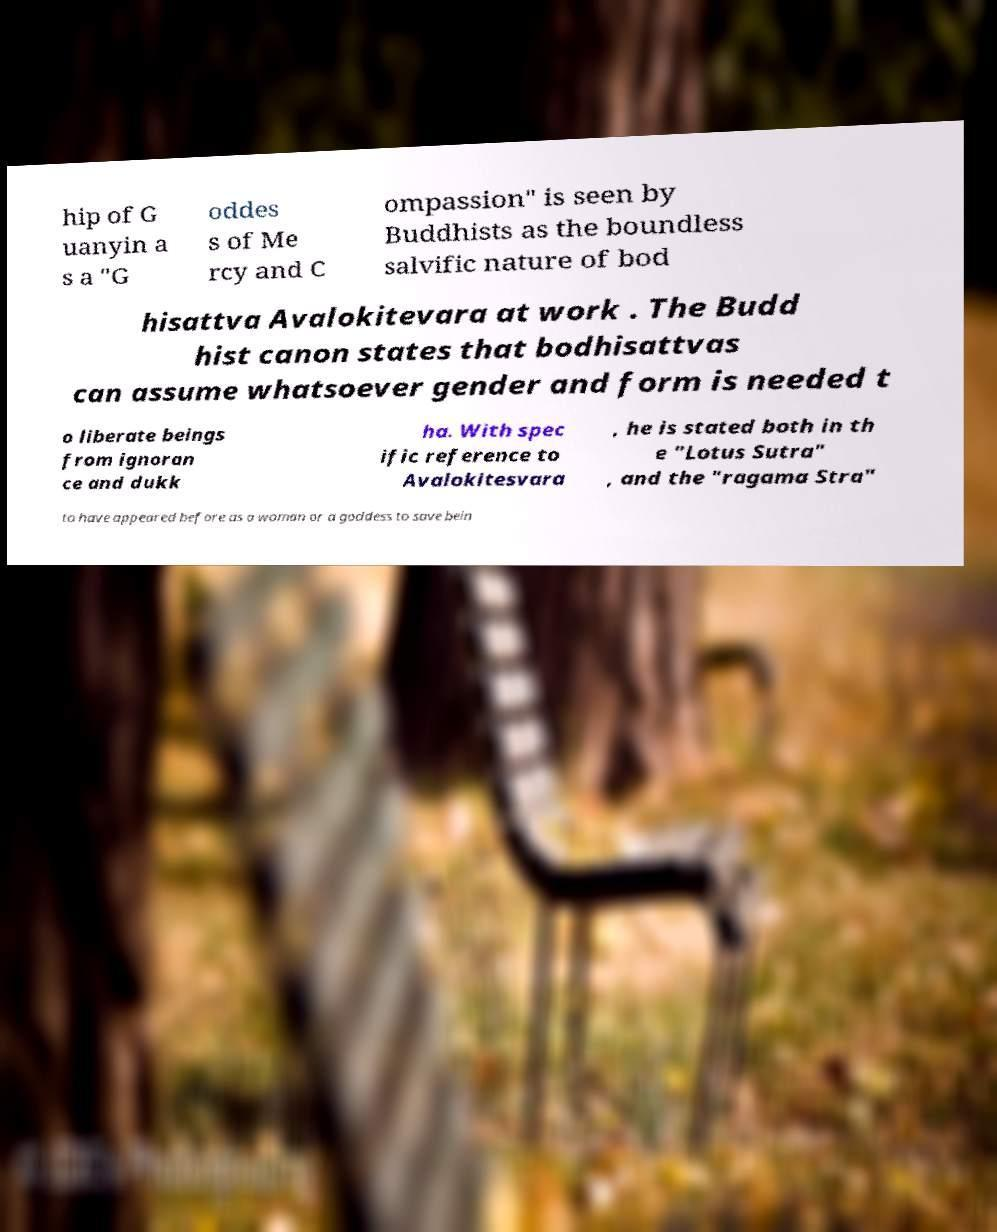Can you accurately transcribe the text from the provided image for me? hip of G uanyin a s a "G oddes s of Me rcy and C ompassion" is seen by Buddhists as the boundless salvific nature of bod hisattva Avalokitevara at work . The Budd hist canon states that bodhisattvas can assume whatsoever gender and form is needed t o liberate beings from ignoran ce and dukk ha. With spec ific reference to Avalokitesvara , he is stated both in th e "Lotus Sutra" , and the "ragama Stra" to have appeared before as a woman or a goddess to save bein 